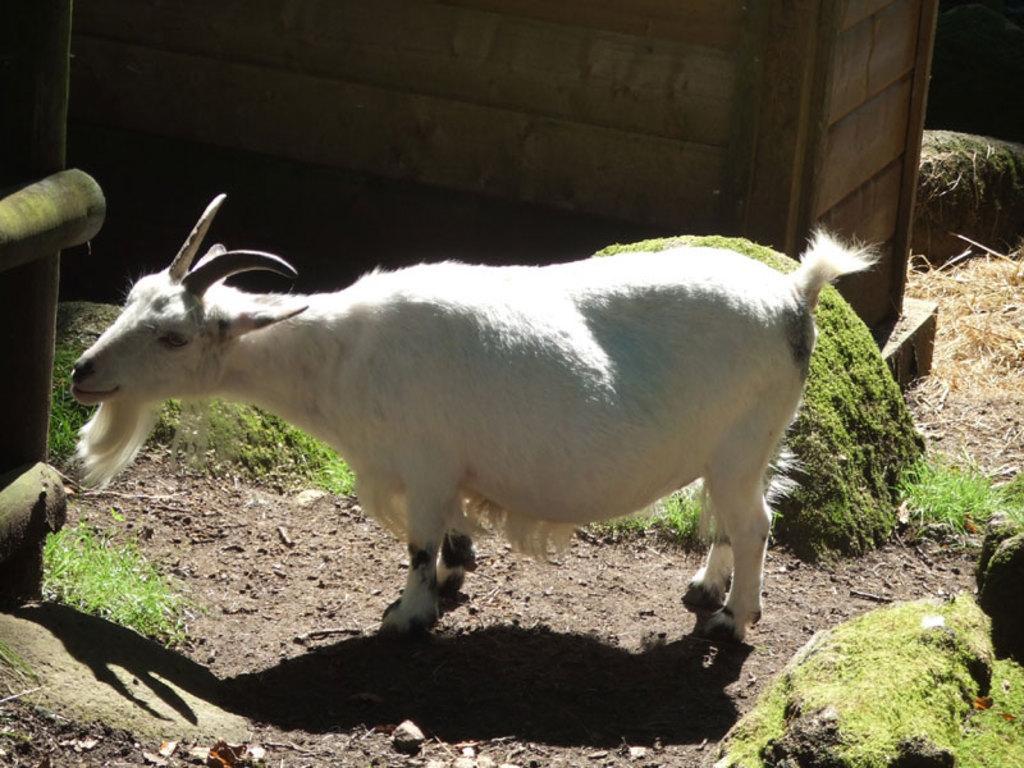Can you describe this image briefly? In this image we can see a white goat on the ground, there is the grass, there are small stones on the ground. 